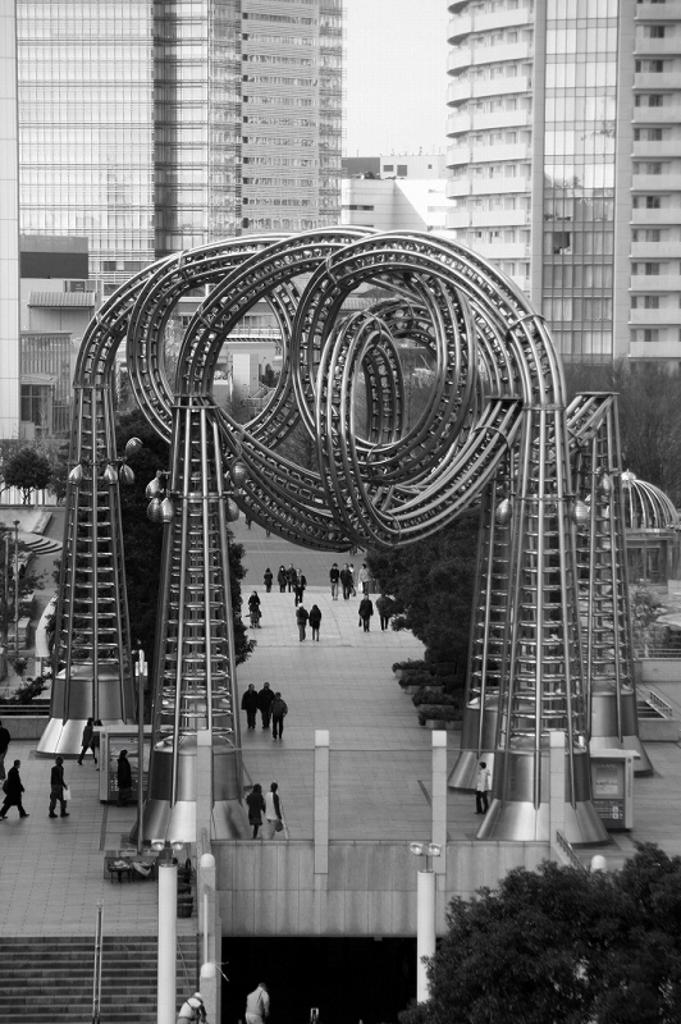What are the people in the image doing? The people in the image are walking. What can be seen in the foreground of the image? There is an unspecified structure in the image. What can be seen in the background of the image? There are buildings visible in the background of the image. Can you see any fingers in the image? There is no mention of fingers or any body parts in the image. 